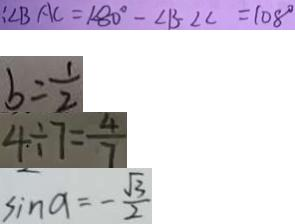<formula> <loc_0><loc_0><loc_500><loc_500>: \angle B A C = 1 8 0 ^ { \circ } - \angle B - \angle C = 1 0 8 ^ { \circ } 
 b = \frac { 1 } { 2 } 
 4 \div 7 = \frac { 4 } { 7 } 
 \sin a = - \frac { \sqrt { 3 } } { 2 }</formula> 